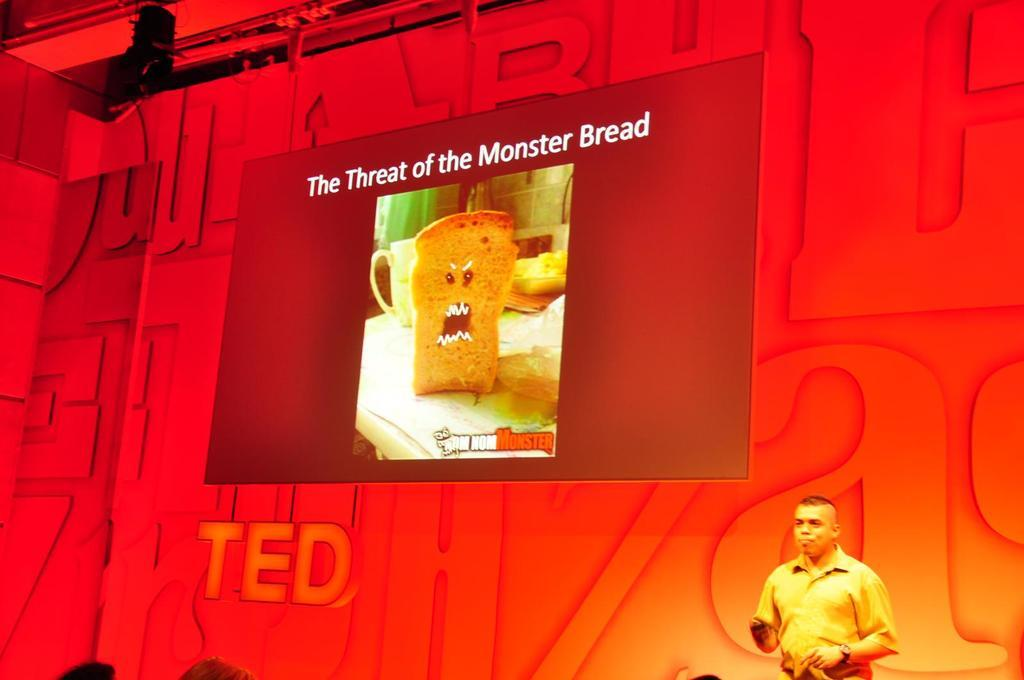What is on the wall in the image? There is a display screen on a wall in the image. What can be seen on the display screen? The display screen has a picture and some text on it. What is present on the roof in the image? There is a light on the roof in the image. Who or what can be seen at the bottom of the image? There are people visible at the bottom of the image. What type of yarn is being used to create the system in the image? There is no yarn or system present in the image; it features a display screen, a light, and people. 